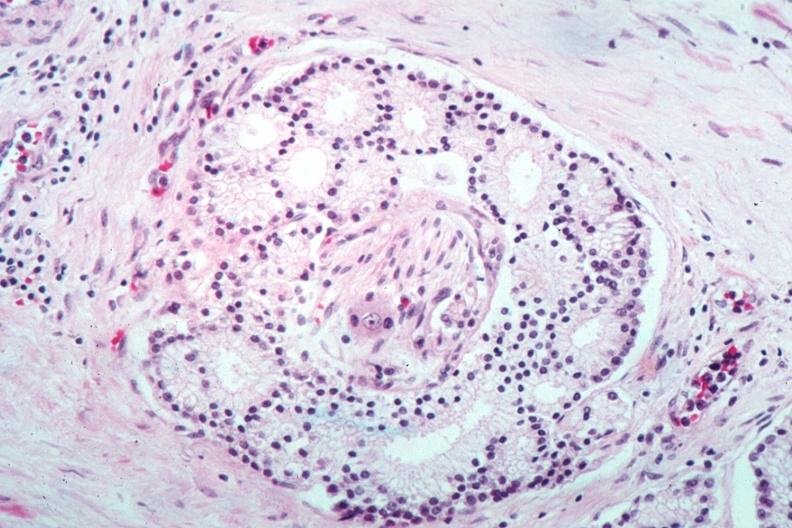how does this image show nice photo of perineural invasion?
Answer the question using a single word or phrase. By well differentiated adenocarcinoma 